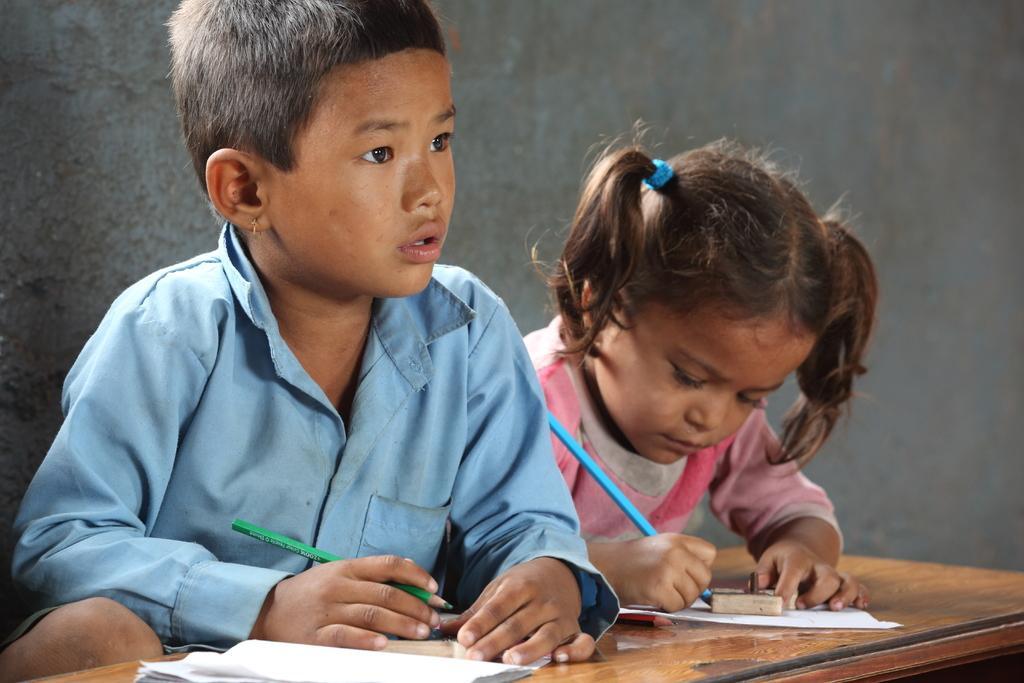Could you give a brief overview of what you see in this image? In this image I can see two persons are holding pencils in their hand and I can see a book, paper and eraser on a table. In the background I can see a wall. This image is taken, may be in a room. 